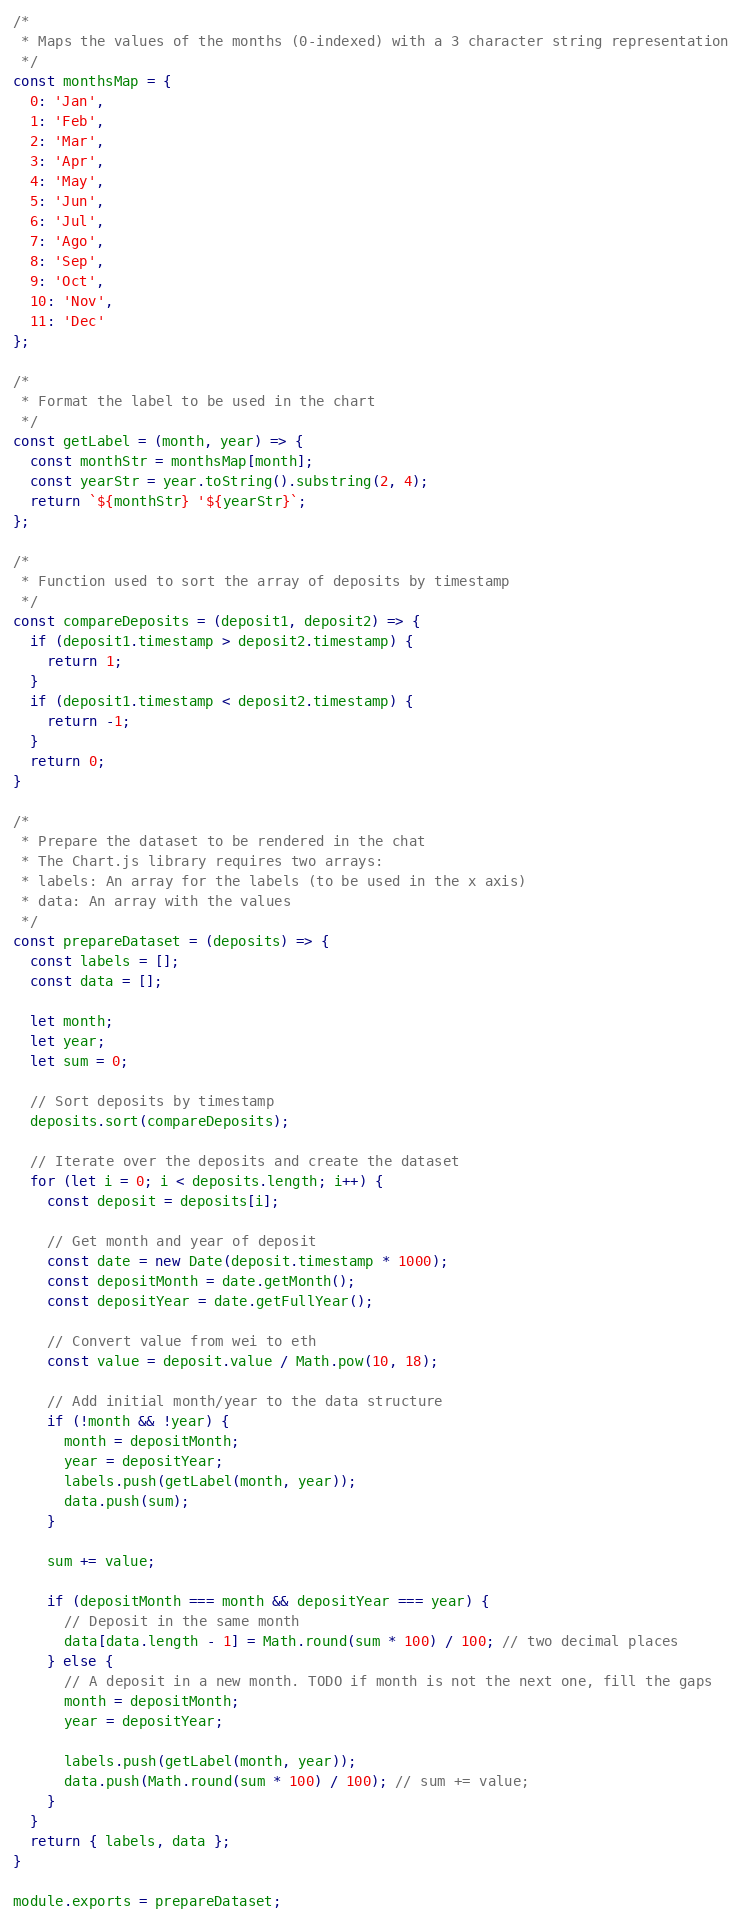<code> <loc_0><loc_0><loc_500><loc_500><_JavaScript_>/*
 * Maps the values of the months (0-indexed) with a 3 character string representation
 */
const monthsMap = {
  0: 'Jan',
  1: 'Feb',
  2: 'Mar',
  3: 'Apr',
  4: 'May',
  5: 'Jun',
  6: 'Jul',
  7: 'Ago',
  8: 'Sep',
  9: 'Oct',
  10: 'Nov',
  11: 'Dec'
};

/*
 * Format the label to be used in the chart
 */
const getLabel = (month, year) => {
  const monthStr = monthsMap[month];
  const yearStr = year.toString().substring(2, 4);
  return `${monthStr} '${yearStr}`;
};

/*
 * Function used to sort the array of deposits by timestamp
 */
const compareDeposits = (deposit1, deposit2) => {
  if (deposit1.timestamp > deposit2.timestamp) {
    return 1;
  }
  if (deposit1.timestamp < deposit2.timestamp) {
    return -1;
  }
  return 0;
}

/*
 * Prepare the dataset to be rendered in the chat
 * The Chart.js library requires two arrays:
 * labels: An array for the labels (to be used in the x axis)
 * data: An array with the values
 */
const prepareDataset = (deposits) => {
  const labels = [];
  const data = [];

  let month;
  let year;
  let sum = 0;
  
  // Sort deposits by timestamp
  deposits.sort(compareDeposits);

  // Iterate over the deposits and create the dataset
  for (let i = 0; i < deposits.length; i++) {
    const deposit = deposits[i];

    // Get month and year of deposit
    const date = new Date(deposit.timestamp * 1000);
    const depositMonth = date.getMonth();
    const depositYear = date.getFullYear();

    // Convert value from wei to eth
    const value = deposit.value / Math.pow(10, 18);

    // Add initial month/year to the data structure
    if (!month && !year) {
      month = depositMonth;
      year = depositYear;
      labels.push(getLabel(month, year));
      data.push(sum);
    }

    sum += value;

    if (depositMonth === month && depositYear === year) {
      // Deposit in the same month
      data[data.length - 1] = Math.round(sum * 100) / 100; // two decimal places
    } else {
      // A deposit in a new month. TODO if month is not the next one, fill the gaps
      month = depositMonth;
      year = depositYear;

      labels.push(getLabel(month, year));
      data.push(Math.round(sum * 100) / 100); // sum += value;
    }
  }
  return { labels, data };
}

module.exports = prepareDataset;
</code> 